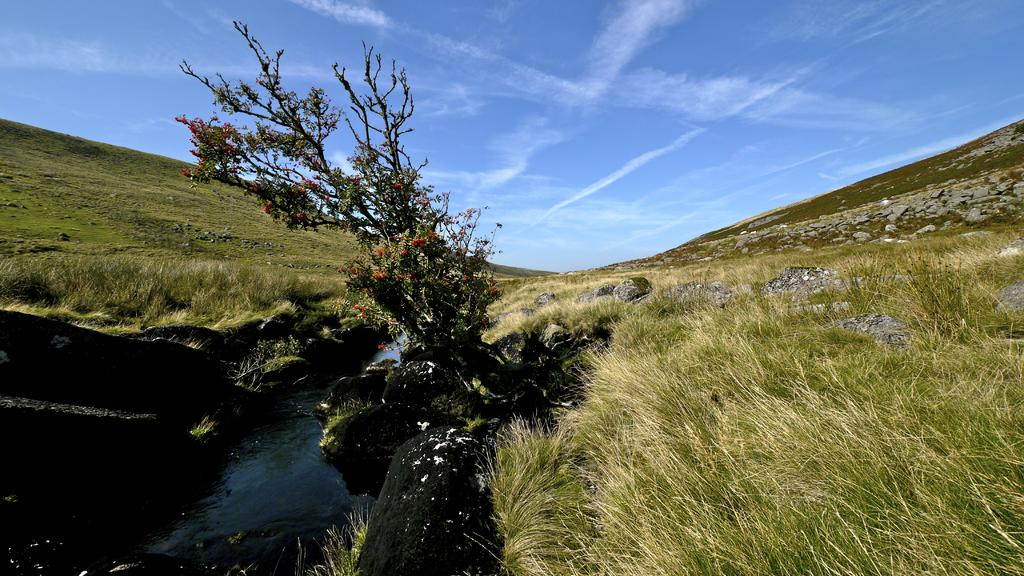What type of natural formation can be seen in the image? There are mountains in the image. What is located in the bottom left of the image? There is a canal in the bottom left of the image. What is situated in the middle of the image? There is a tree in the middle of the image. What type of vegetation is present beside the tree? There is grass beside the tree. What can be seen in the background of the image? The sky is visible in the background of the image. What type of stew is being prepared on the tree in the image? There is no stew or cooking activity present in the image; it features a tree with grass beside it. Can you tell me how many carpenters are working on the mountains in the image? There are no carpenters or any construction activity present in the image; it features mountains, a canal, a tree, grass, and the sky. 